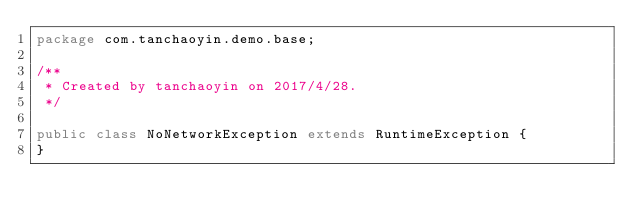Convert code to text. <code><loc_0><loc_0><loc_500><loc_500><_Java_>package com.tanchaoyin.demo.base;

/**
 * Created by tanchaoyin on 2017/4/28.
 */

public class NoNetworkException extends RuntimeException {
}
</code> 